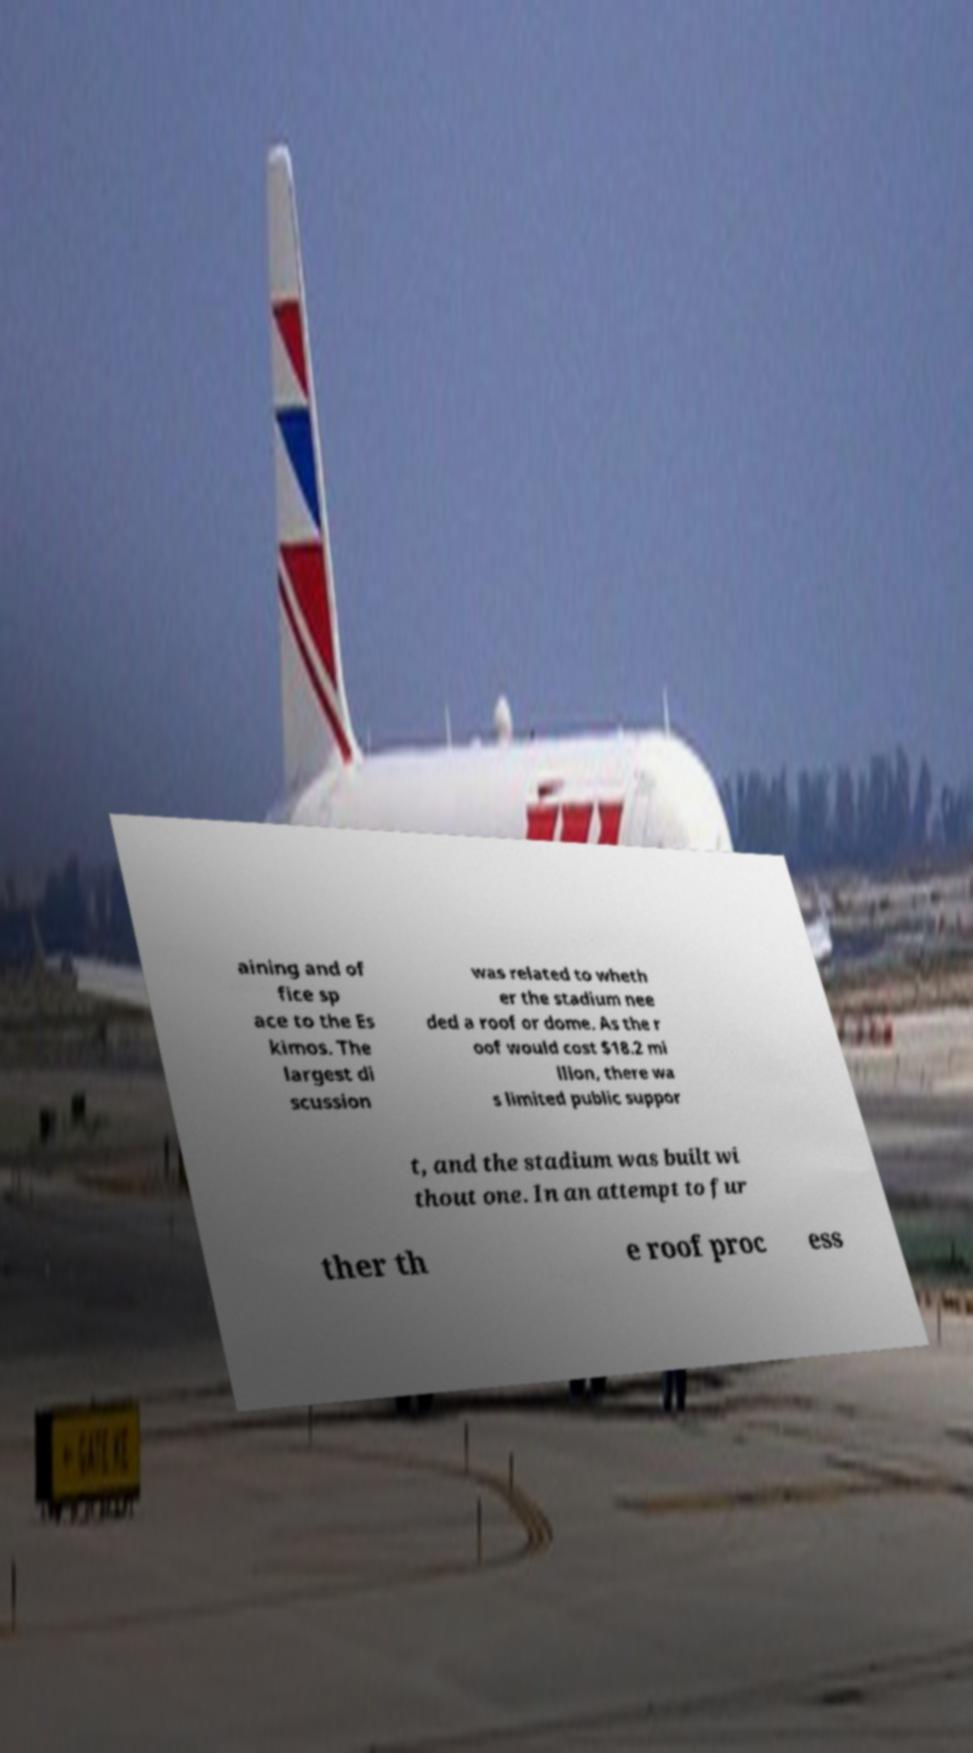Please identify and transcribe the text found in this image. aining and of fice sp ace to the Es kimos. The largest di scussion was related to wheth er the stadium nee ded a roof or dome. As the r oof would cost $18.2 mi llion, there wa s limited public suppor t, and the stadium was built wi thout one. In an attempt to fur ther th e roof proc ess 